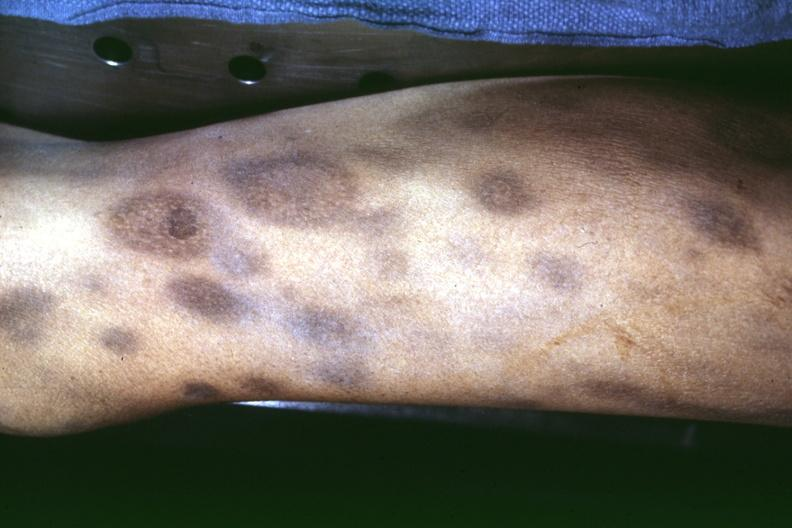what looks like pyoderma gangrenosum?
Answer the question using a single word or phrase. Necrotic appearing centers 